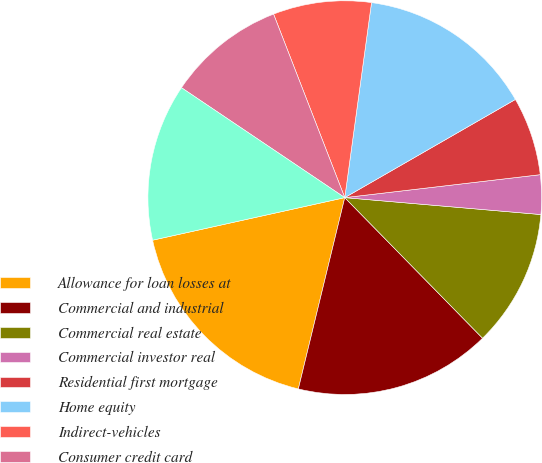<chart> <loc_0><loc_0><loc_500><loc_500><pie_chart><fcel>Allowance for loan losses at<fcel>Commercial and industrial<fcel>Commercial real estate<fcel>Commercial investor real<fcel>Residential first mortgage<fcel>Home equity<fcel>Indirect-vehicles<fcel>Consumer credit card<fcel>Other consumer<nl><fcel>17.74%<fcel>16.13%<fcel>11.29%<fcel>3.23%<fcel>6.45%<fcel>14.52%<fcel>8.06%<fcel>9.68%<fcel>12.9%<nl></chart> 